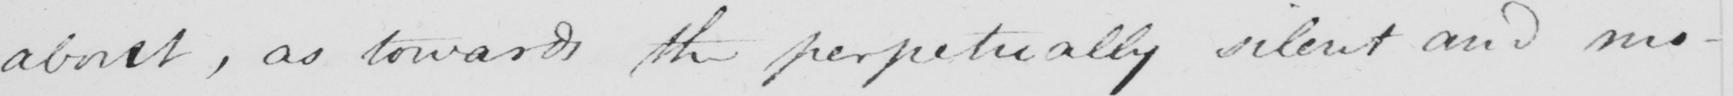Can you read and transcribe this handwriting? about , as towards the perpetually silent and mo- 